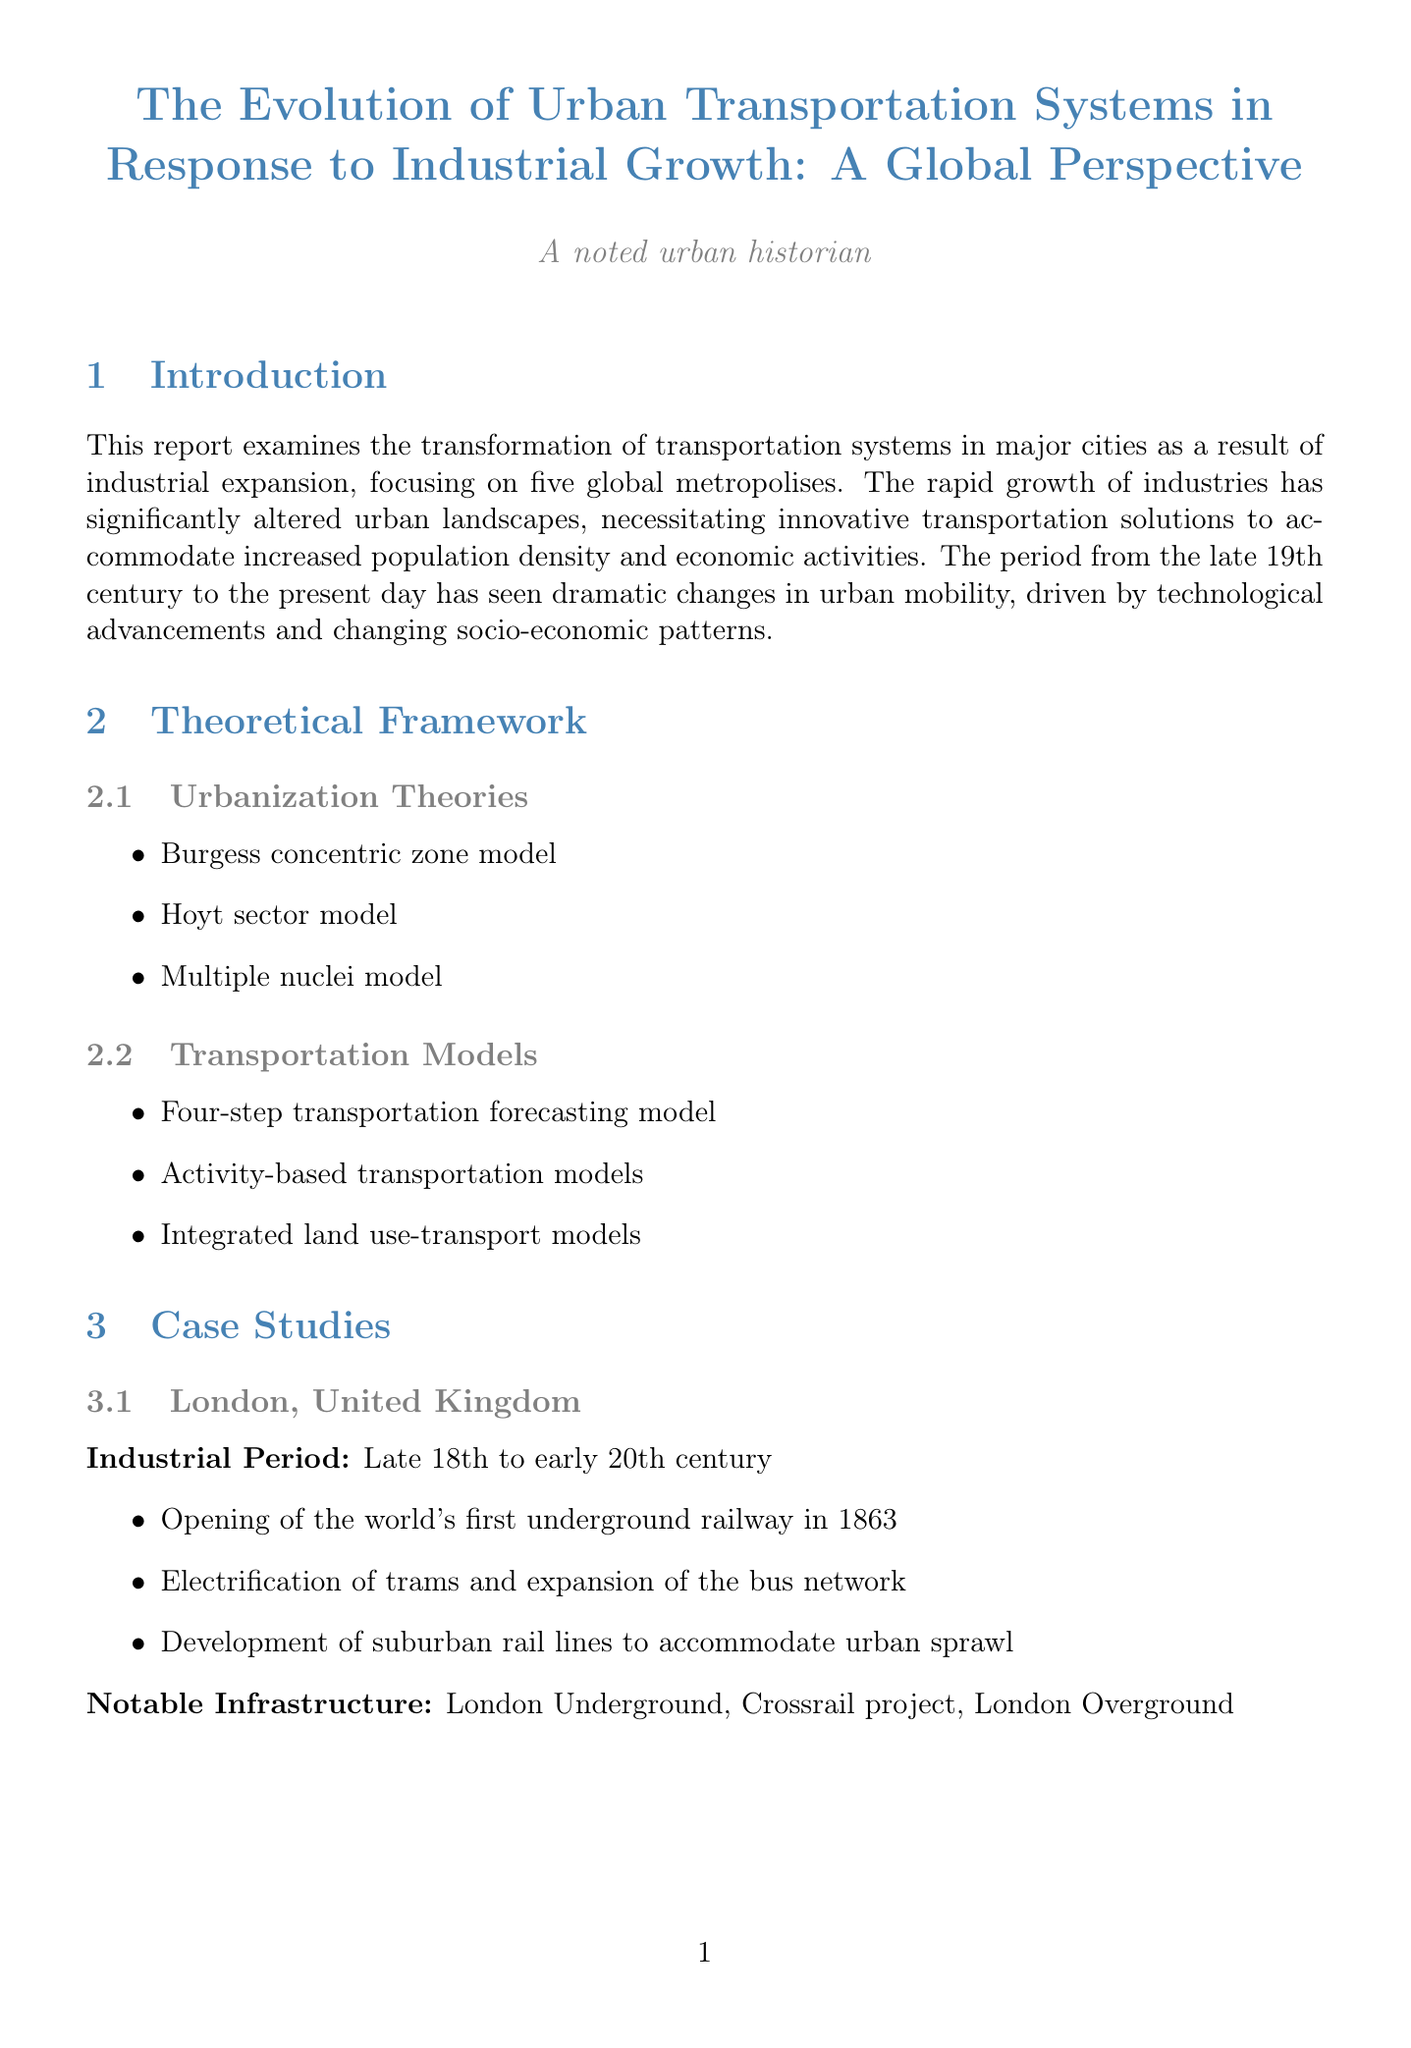What is the title of the report? The title of the report is explicitly mentioned at the top of the document.
Answer: The Evolution of Urban Transportation Systems in Response to Industrial Growth: A Global Perspective Which city is associated with the world's first underground railway? This information is found in the case study of London, United Kingdom.
Answer: London In which century did the industrial period of São Paulo occur? The industrial period for São Paulo is specified within its case study section.
Answer: Early to mid-20th century What is one notable infrastructure of New York City? This information can be retrieved from the key developments listed in the New York City case study.
Answer: New York City Subway What are two common trends identified in the comparative analysis? The document lists common trends in the section detailing comparative analysis.
Answer: Shift from surface-level to multi-level transportation systems, Integration of various modes of transport What is a modern challenge mentioned in the document? This question pertains to the modern challenges outlined in the environmental impact section.
Answer: Greenhouse gas emissions Which technology is mentioned as an emerging technology for the future? This information is provided in the future prospects section under emerging technologies.
Answer: Autonomous vehicles What does the conclusion suggest for future research? This can be found in the conclusion where future research directions are discussed.
Answer: Further studies are needed to explore the potential of emerging technologies in addressing the transportation challenges of rapidly industrializing cities in the Global South 